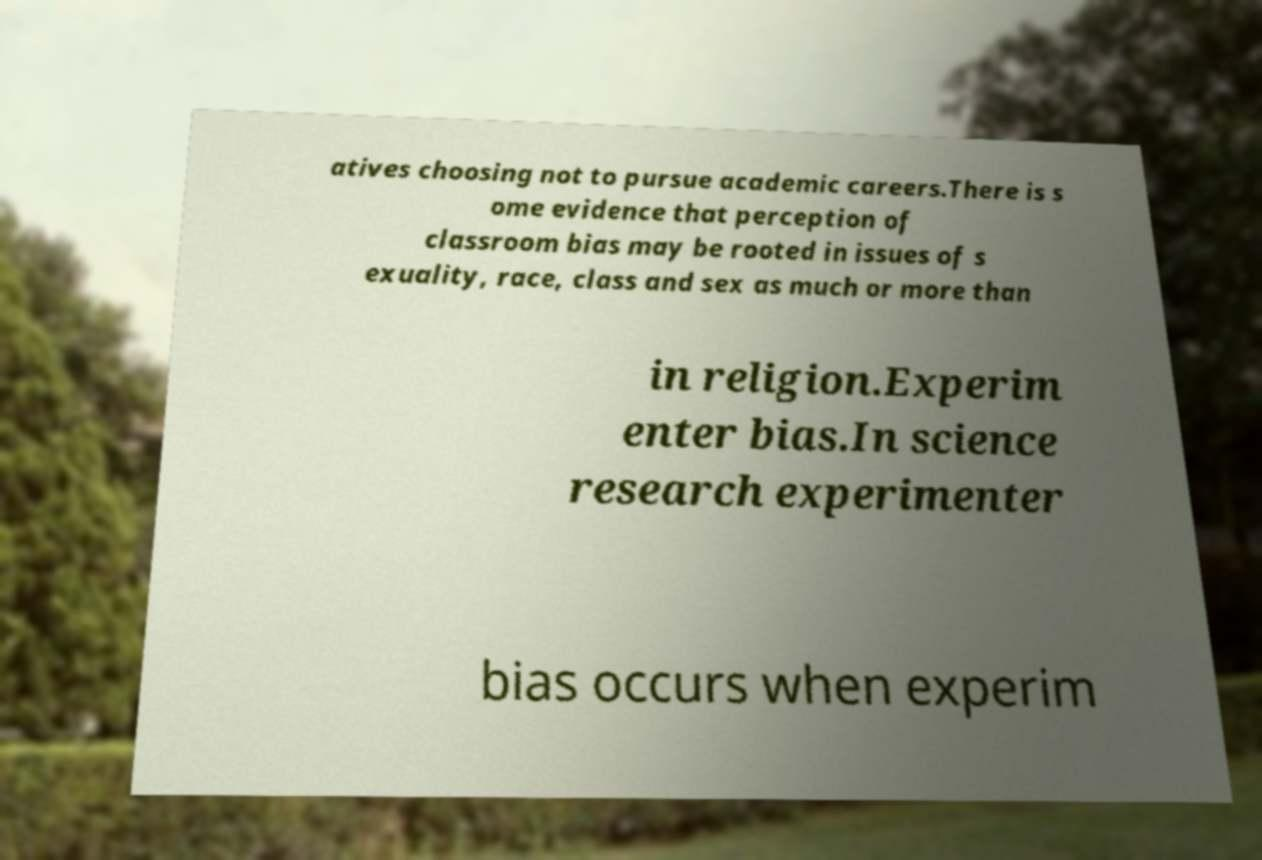Could you assist in decoding the text presented in this image and type it out clearly? atives choosing not to pursue academic careers.There is s ome evidence that perception of classroom bias may be rooted in issues of s exuality, race, class and sex as much or more than in religion.Experim enter bias.In science research experimenter bias occurs when experim 